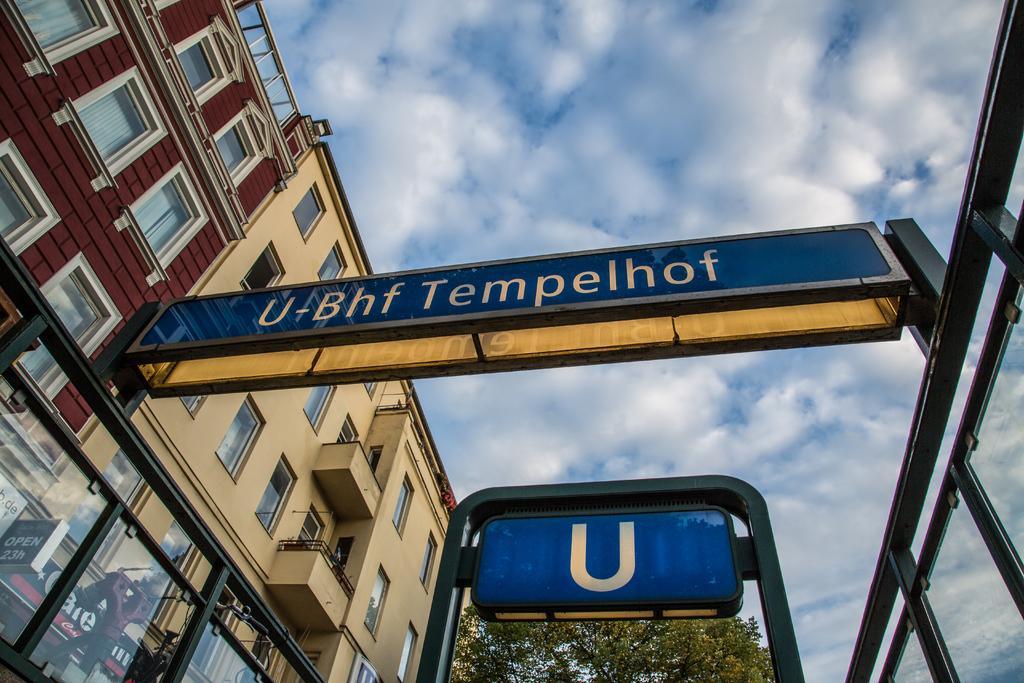Can you describe this image briefly? In the center of the image we can see a sign board. On the left side of the image there is a building. At the bottom of the image there is a tree and sign board. In the background there is a sky and clouds. 